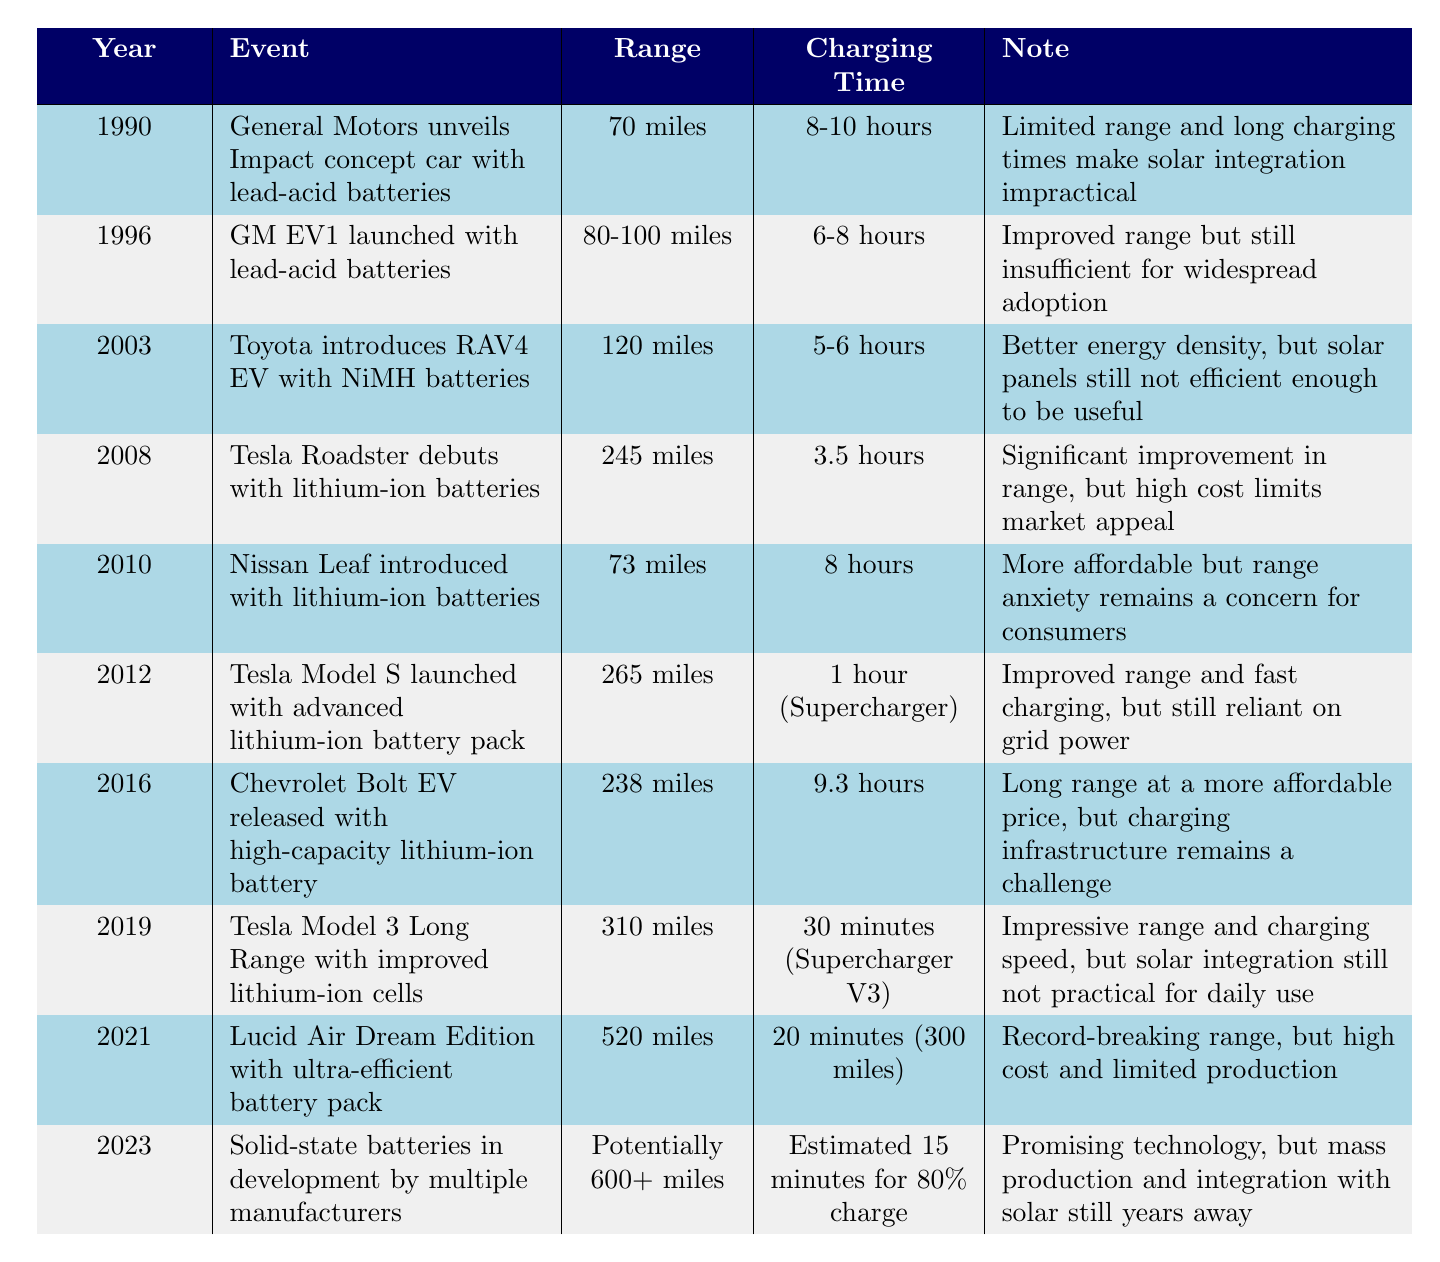What range does the Tesla Model 3 Long Range have? According to the table, the Tesla Model 3 Long Range was introduced in 2019 and has a range of 310 miles.
Answer: 310 miles What was the charging time for the Lucid Air Dream Edition? The table states that the Lucid Air Dream Edition, launched in 2021, has a charging time of 20 minutes for 300 miles.
Answer: 20 minutes Which vehicle in the timeline has the longest range? The table lists the Lucid Air Dream Edition with a range of 520 miles as the vehicle with the longest range.
Answer: Lucid Air Dream Edition Is the range of the Nissan Leaf greater than the range of the Toyota RAV4 EV? The Nissan Leaf has a range of 73 miles while the Toyota RAV4 EV has a range of 120 miles, so the statement is false.
Answer: No What is the percentage increase in range from the GM EV1 (1996) to the Tesla Model S (2012)? The GM EV1 has a range of 80-100 miles (we can consider 90 miles as an estimate) and the Tesla Model S has a range of 265 miles. The increase in range is calculated as (265 - 90) / 90 = 1.944 or 194.4%.
Answer: 194.4% What are the charging times of the Tesla Roadster and Tesla Model S? The Tesla Roadster has a charging time of 3.5 hours, while the Tesla Model S has a Supercharger charging time of 1 hour. This indicates that the Model S charges faster.
Answer: 3.5 hours and 1 hour In what year was the first vehicle utilizing lithium-ion batteries released? The table shows that the Tesla Roadster debuted in 2008, marking it as the first vehicle utilizing lithium-ion batteries.
Answer: 2008 Are solid-state batteries expected to increase the range of electric vehicles beyond 600 miles? The note in the table states that solid-state batteries are in development and have the potential for 600+ miles, which confirms that they may indeed increase the range beyond that point.
Answer: Yes 